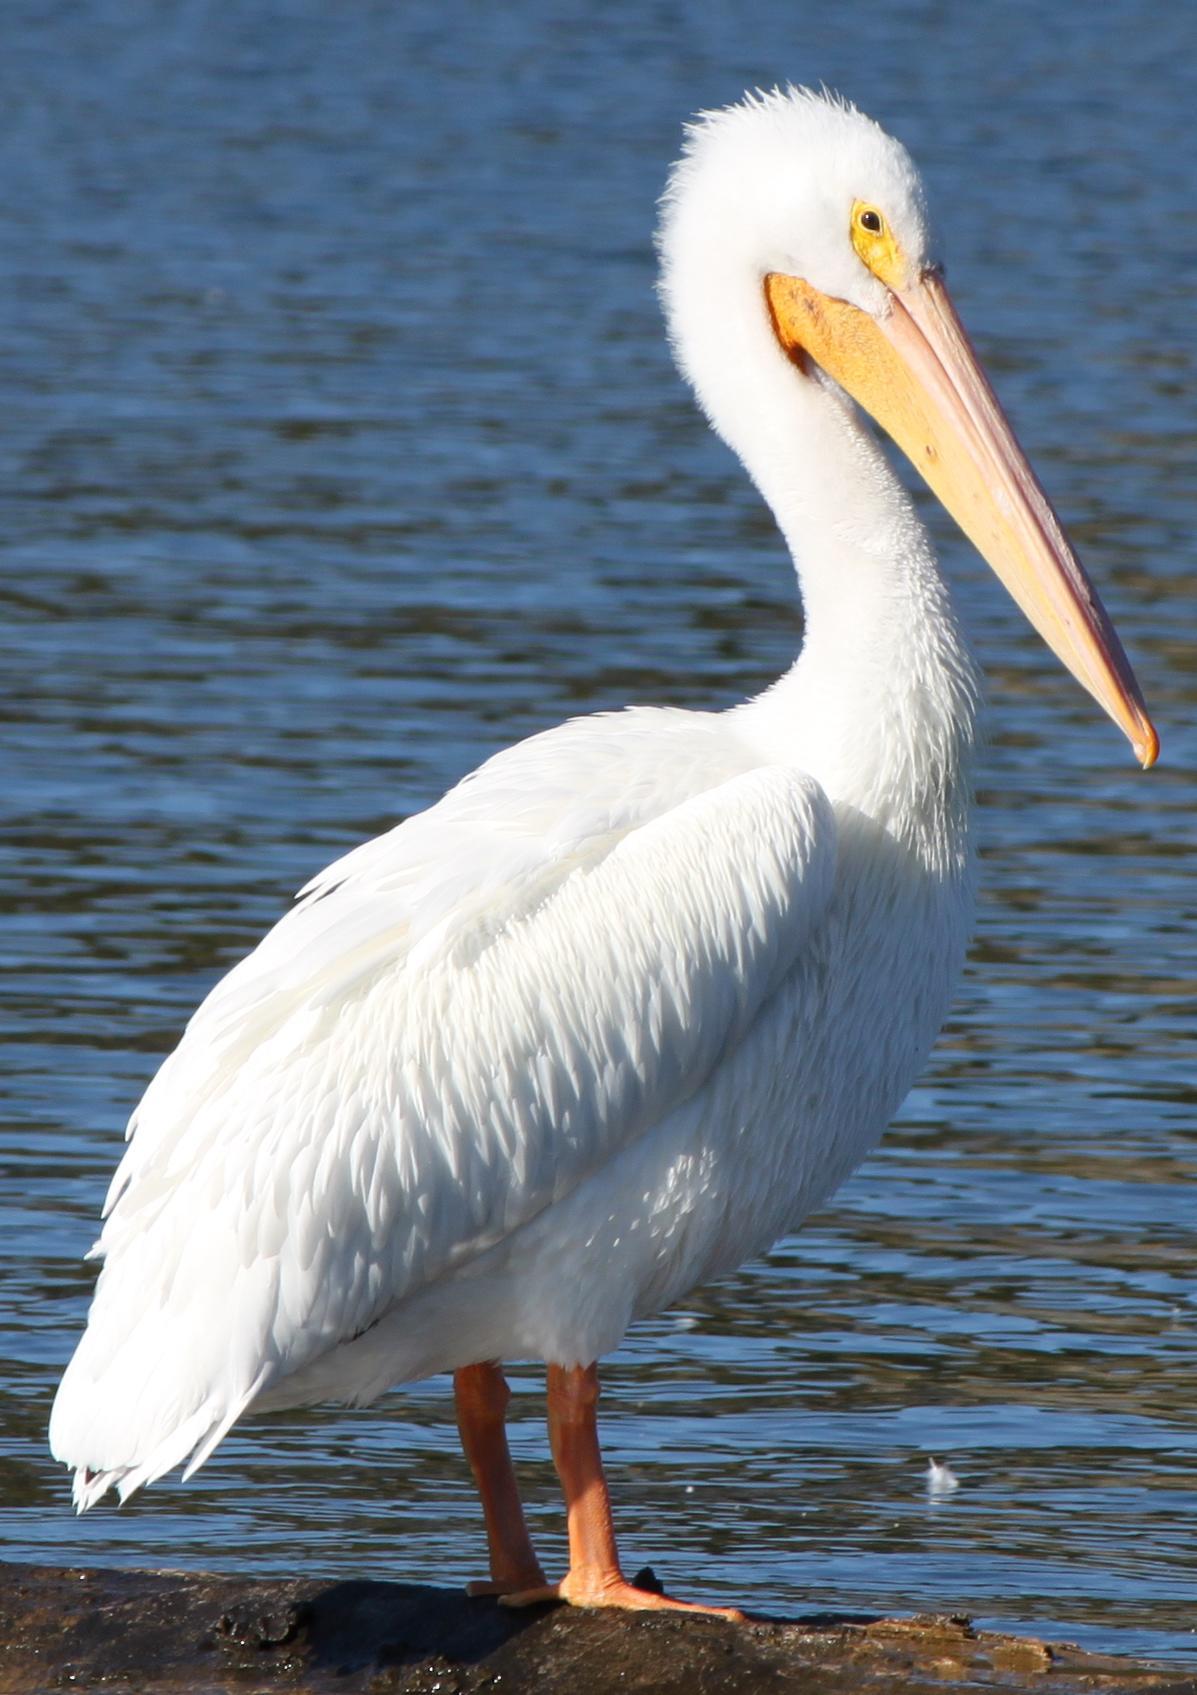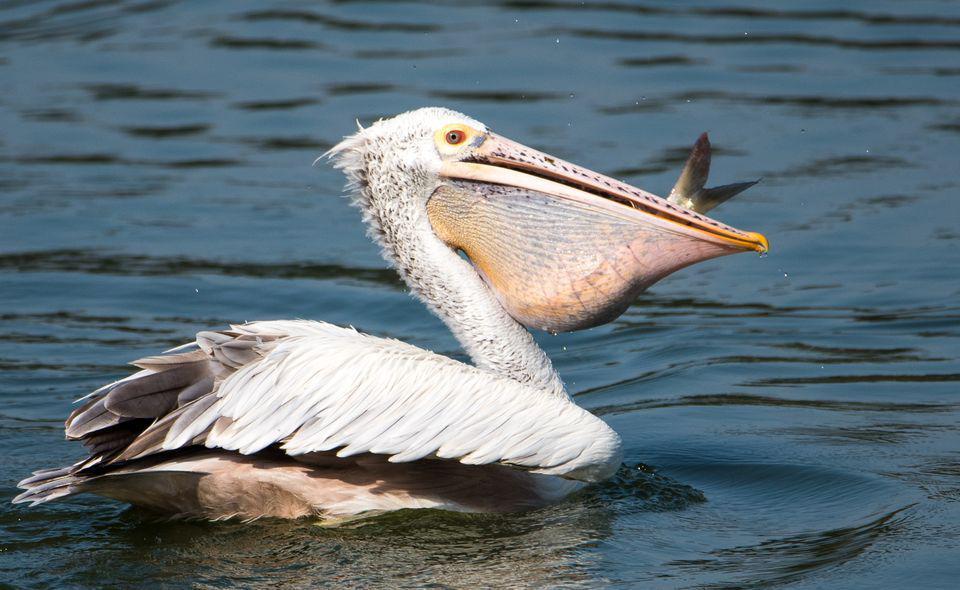The first image is the image on the left, the second image is the image on the right. Given the left and right images, does the statement "One of the birds has its wings spread." hold true? Answer yes or no. No. 